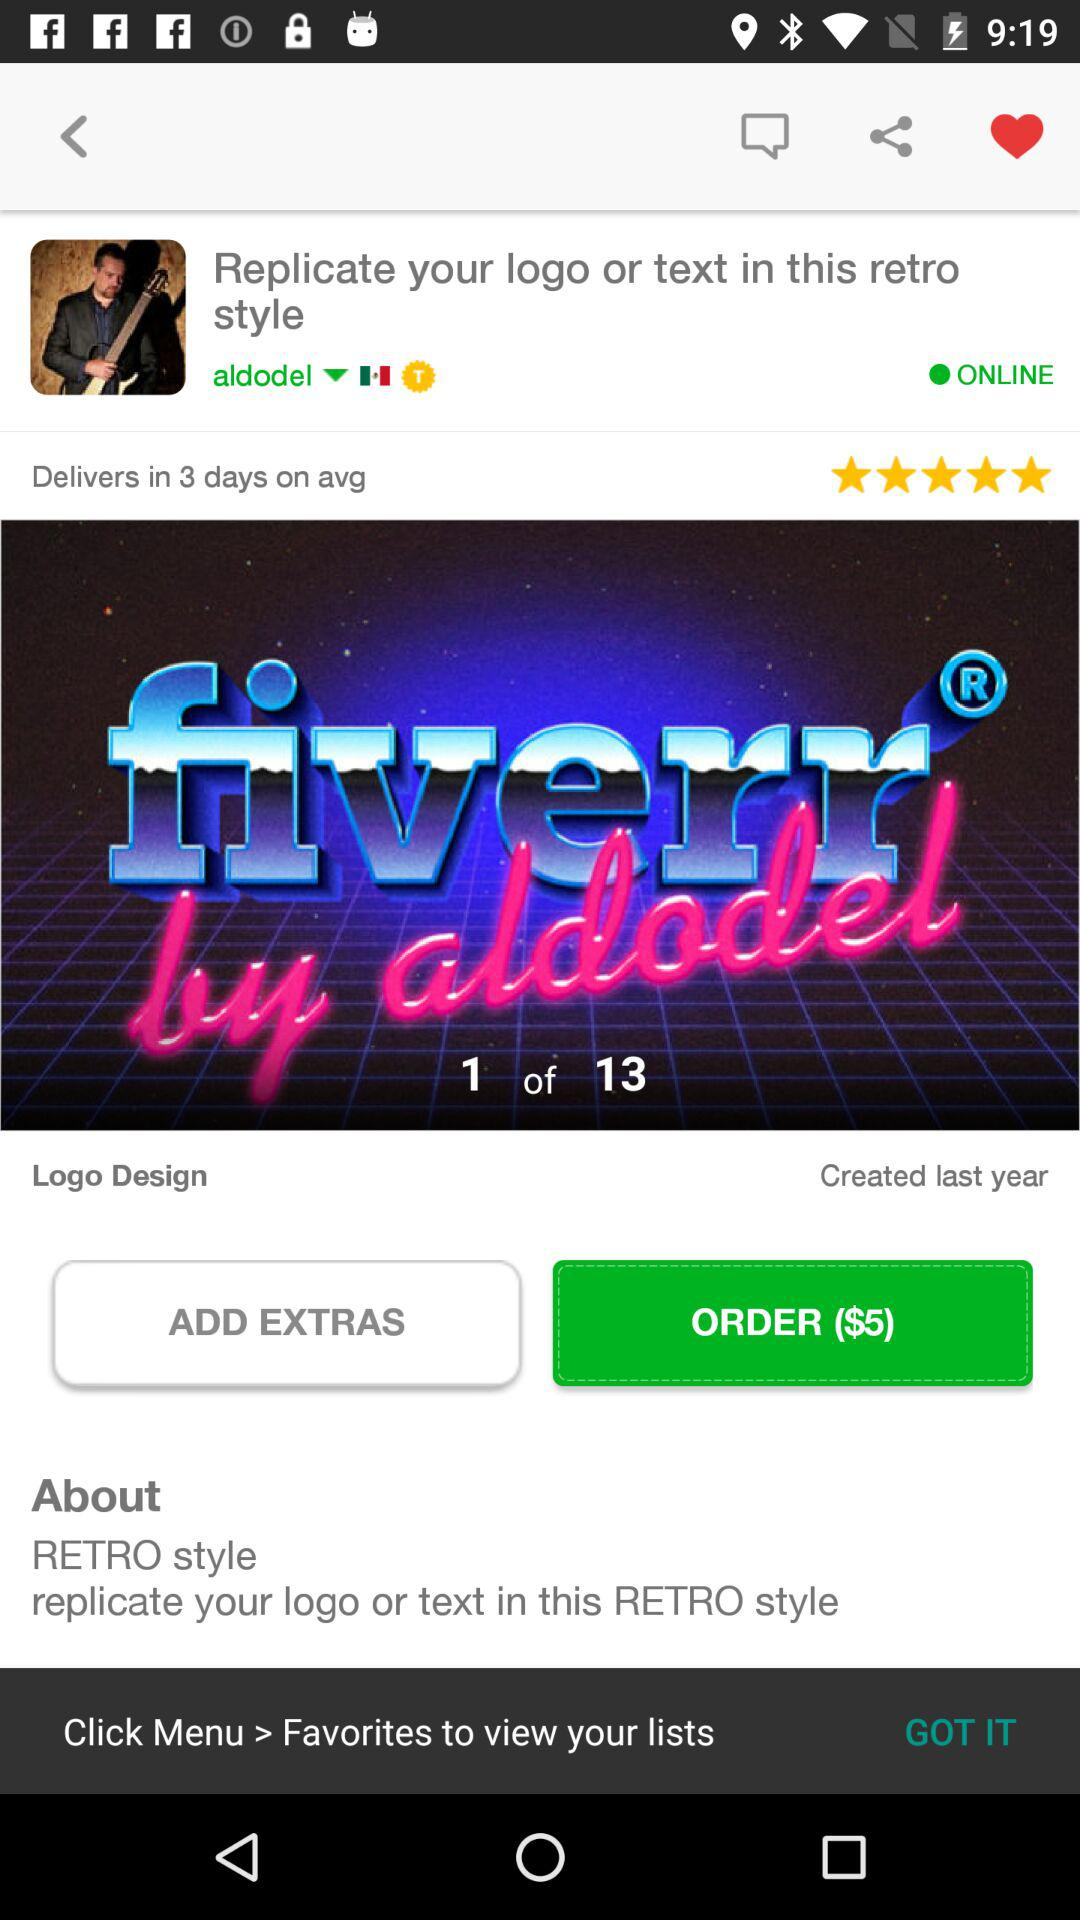What is the rating? The rating is 5 stars. 